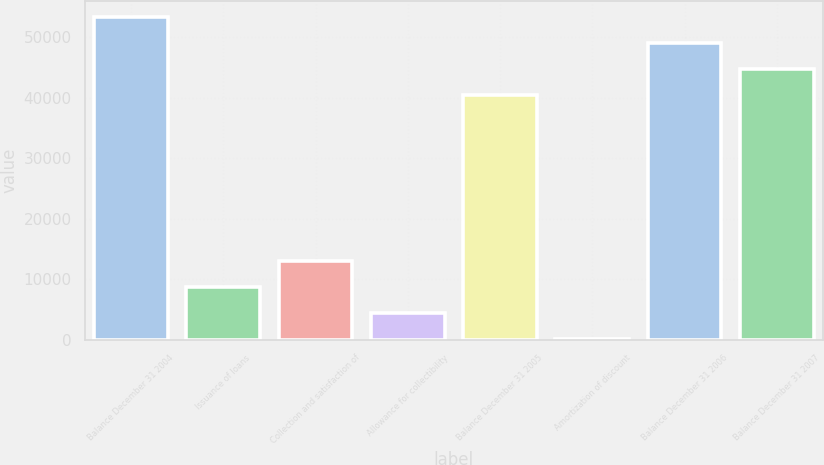Convert chart. <chart><loc_0><loc_0><loc_500><loc_500><bar_chart><fcel>Balance December 31 2004<fcel>Issuance of loans<fcel>Collection and satisfaction of<fcel>Allowance for collectibility<fcel>Balance December 31 2005<fcel>Amortization of discount<fcel>Balance December 31 2006<fcel>Balance December 31 2007<nl><fcel>53332<fcel>8773<fcel>13040<fcel>4506<fcel>40531<fcel>239<fcel>49065<fcel>44798<nl></chart> 